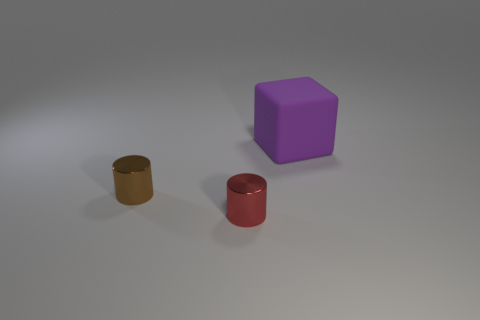Is there anything else that has the same size as the purple cube?
Provide a succinct answer. No. How many metal objects are small green things or small red things?
Your answer should be very brief. 1. Are there fewer tiny red metal objects that are right of the small red object than purple things that are behind the large purple object?
Your answer should be compact. No. How many objects are large rubber blocks or things on the left side of the matte block?
Give a very brief answer. 3. Is the large purple cube made of the same material as the tiny brown object?
Keep it short and to the point. No. There is a thing that is on the left side of the rubber block and behind the small red shiny thing; what color is it?
Keep it short and to the point. Brown. The red shiny thing that is the same size as the brown shiny object is what shape?
Offer a very short reply. Cylinder. What number of other objects are there of the same material as the large purple thing?
Your response must be concise. 0. There is a matte block; is it the same size as the metal thing that is on the right side of the tiny brown metal cylinder?
Provide a succinct answer. No. The block is what color?
Your answer should be very brief. Purple. 